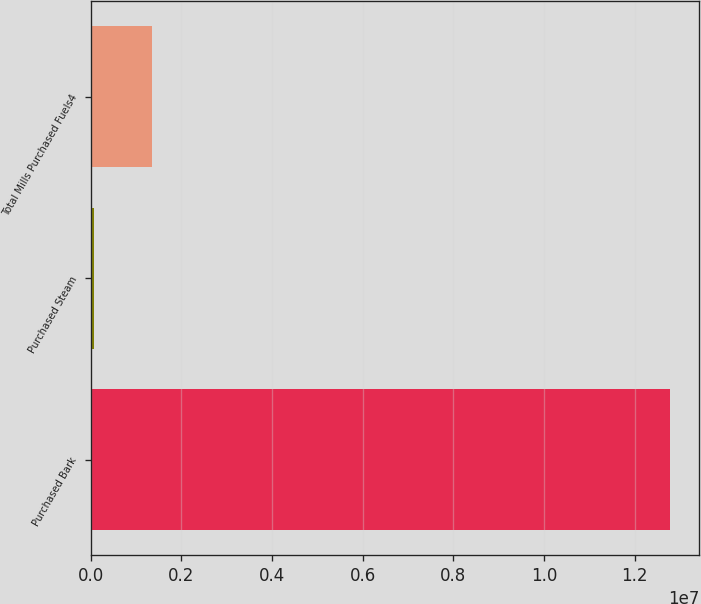<chart> <loc_0><loc_0><loc_500><loc_500><bar_chart><fcel>Purchased Bark<fcel>Purchased Steam<fcel>Total Mills Purchased Fuels4<nl><fcel>1.27871e+07<fcel>81925<fcel>1.35244e+06<nl></chart> 